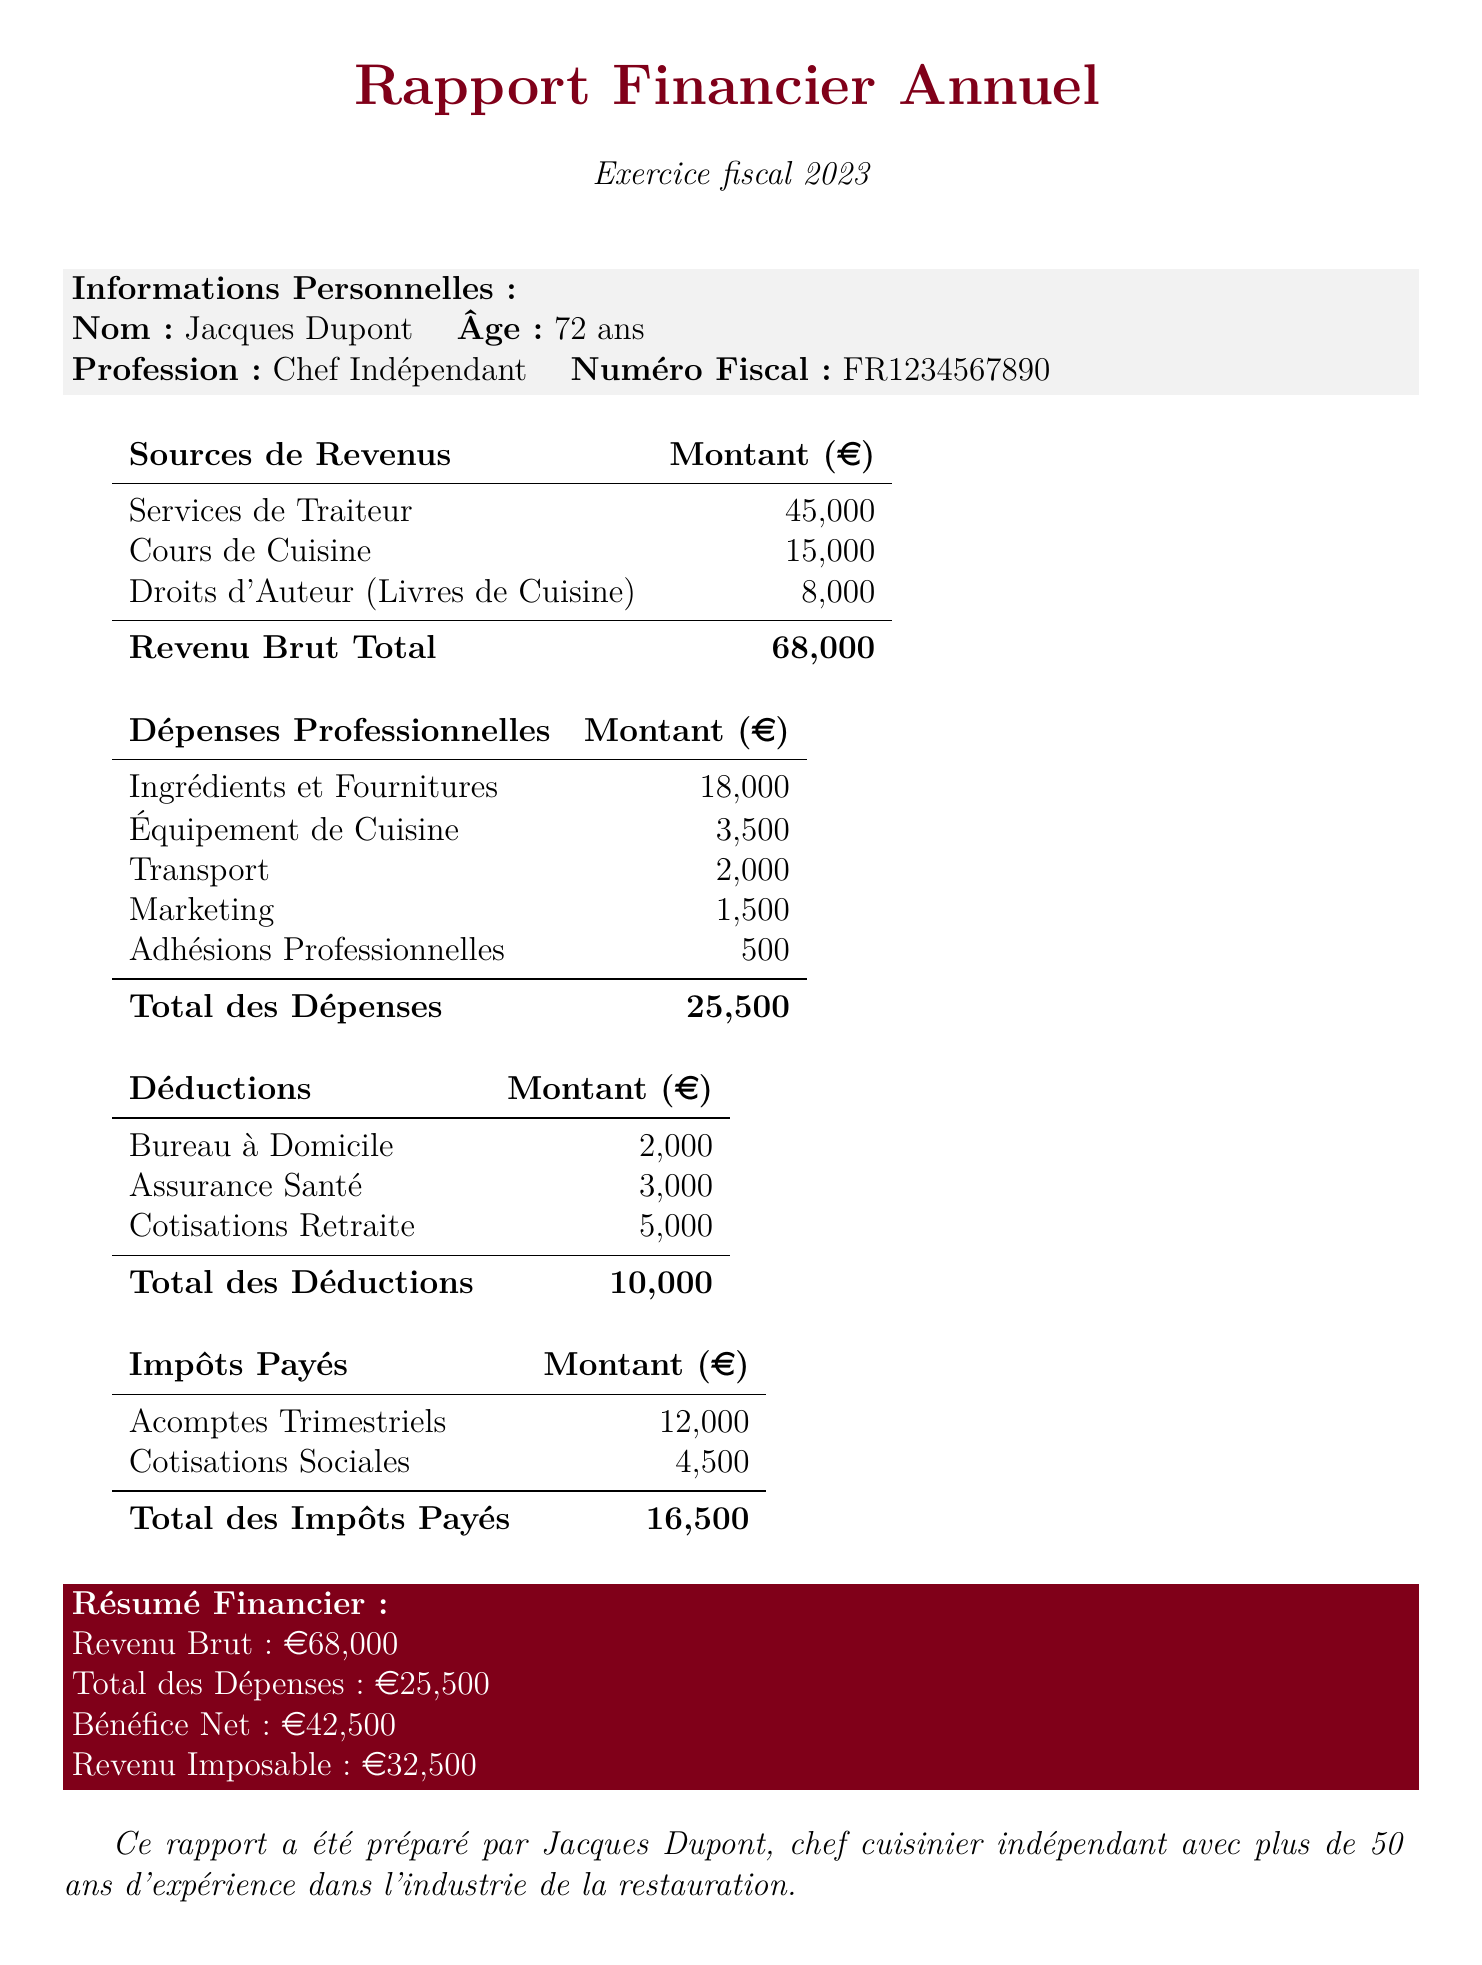What is the name of the self-employed chef? The document provides personal information about the chef, including his name.
Answer: Jacques Dupont What is the total revenue from cooking classes? The document specifies the revenue generated from cooking classes as one of the income sources.
Answer: 15000 Which clients are mentioned under catering services? The document lists major clients associated with catering services.
Answer: Le Petit Bistro, Château de Versailles What are the total business expenses? The total business expenses are calculated by summing up the individual expense categories listed in the document.
Answer: 25500 What is the amount of retirement contributions deducted? The document highlights specific deductions, including retirement contributions.
Answer: 5000 What is the net profit reported in the summary? The summary at the end of the document provides the net profit after deducting total expenses from gross income.
Answer: 42500 How much was paid in quarterly estimated taxes? The amount paid in quarterly estimated taxes is listed under taxes paid in the document.
Answer: 12000 What is the taxable income calculated? The taxable income is derived from the net profit after deducting total deductions, explicitly mentioned in the summary.
Answer: 32500 How many years of experience does Jacques Dupont have in the restaurant industry? The document includes a statement about the chef’s experience in the closing remarks.
Answer: 50 